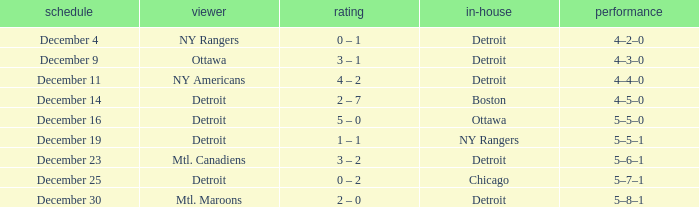What record has detroit as the home and mtl. maroons as the visitor? 5–8–1. 